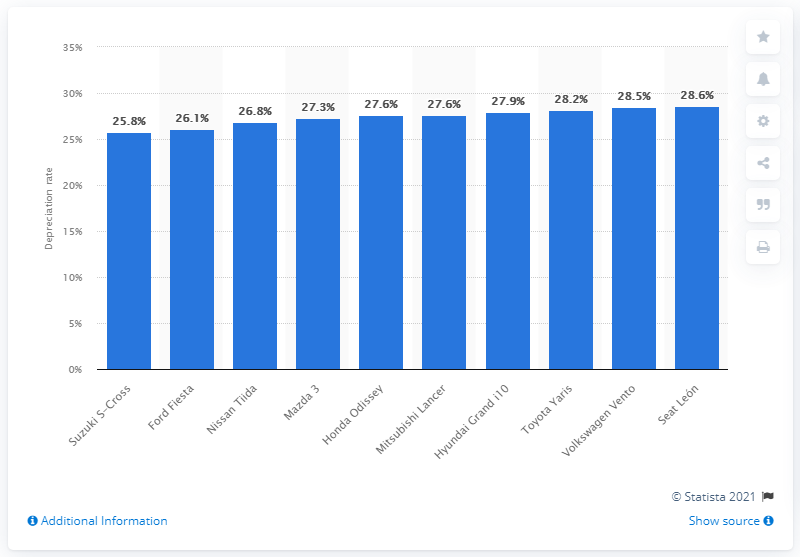Outline some significant characteristics in this image. The Suzuki S-Cross had the lowest depreciation rate among car models in Mexico in both 2016 and 2017. The depreciation rate of the Suzuki S-Cross was 25.8%. 